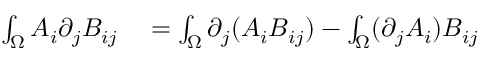<formula> <loc_0><loc_0><loc_500><loc_500>\begin{array} { r l } { \int _ { \Omega } A _ { i } \partial _ { j } B _ { i j } } & = \int _ { \Omega } \partial _ { j } ( A _ { i } B _ { i j } ) - \int _ { \Omega } ( \partial _ { j } A _ { i } ) B _ { i j } } \end{array}</formula> 